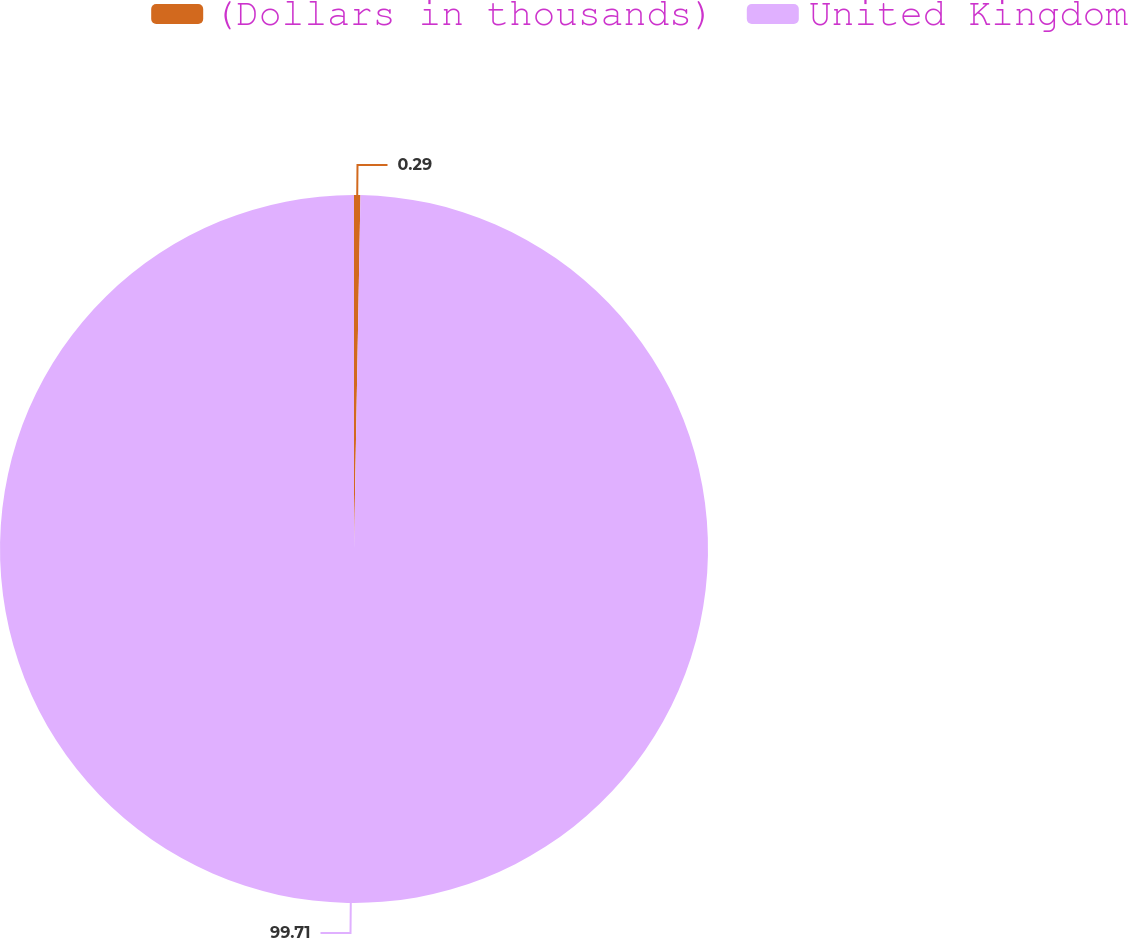<chart> <loc_0><loc_0><loc_500><loc_500><pie_chart><fcel>(Dollars in thousands)<fcel>United Kingdom<nl><fcel>0.29%<fcel>99.71%<nl></chart> 